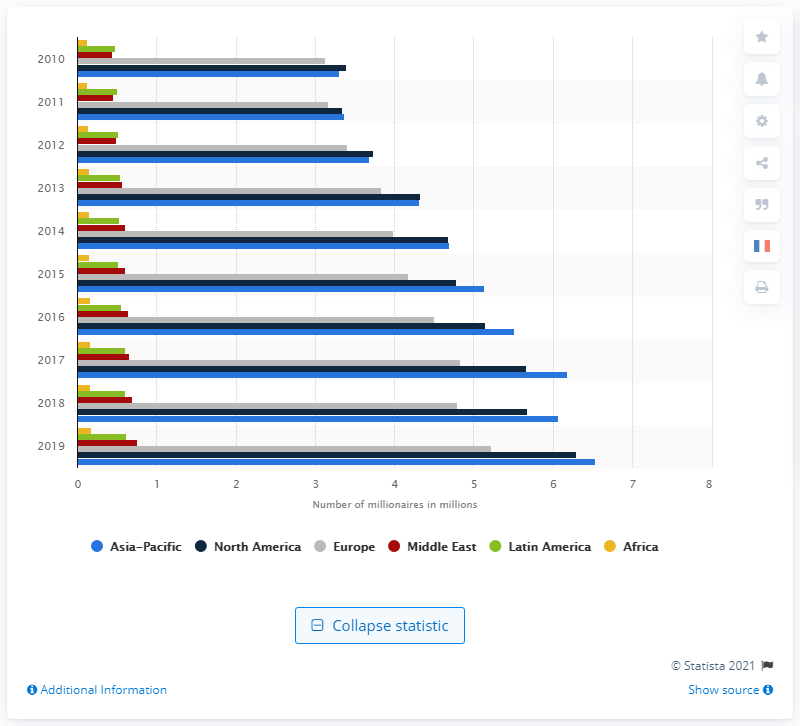List a handful of essential elements in this visual. There were approximately 6.53 million millionaires in the Asia Pacific region in 2019. 